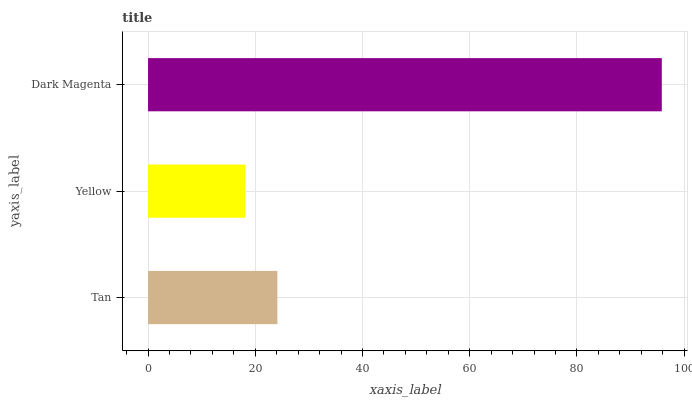Is Yellow the minimum?
Answer yes or no. Yes. Is Dark Magenta the maximum?
Answer yes or no. Yes. Is Dark Magenta the minimum?
Answer yes or no. No. Is Yellow the maximum?
Answer yes or no. No. Is Dark Magenta greater than Yellow?
Answer yes or no. Yes. Is Yellow less than Dark Magenta?
Answer yes or no. Yes. Is Yellow greater than Dark Magenta?
Answer yes or no. No. Is Dark Magenta less than Yellow?
Answer yes or no. No. Is Tan the high median?
Answer yes or no. Yes. Is Tan the low median?
Answer yes or no. Yes. Is Dark Magenta the high median?
Answer yes or no. No. Is Dark Magenta the low median?
Answer yes or no. No. 